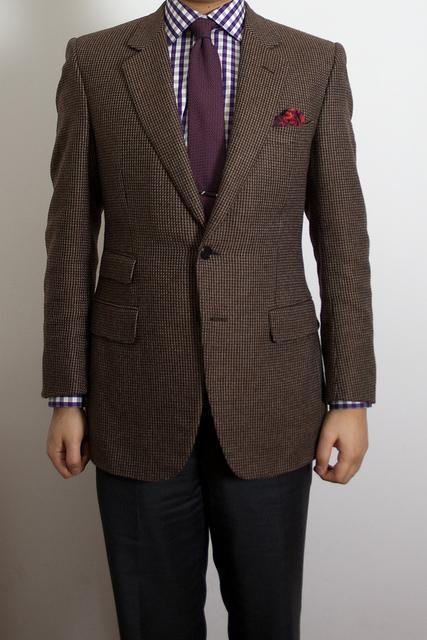How many people can be seen?
Give a very brief answer. 1. 